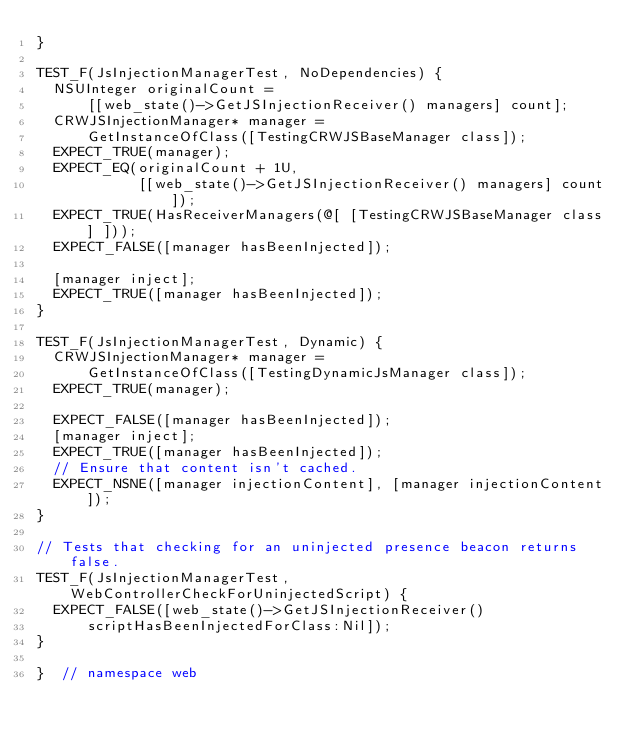<code> <loc_0><loc_0><loc_500><loc_500><_ObjectiveC_>}

TEST_F(JsInjectionManagerTest, NoDependencies) {
  NSUInteger originalCount =
      [[web_state()->GetJSInjectionReceiver() managers] count];
  CRWJSInjectionManager* manager =
      GetInstanceOfClass([TestingCRWJSBaseManager class]);
  EXPECT_TRUE(manager);
  EXPECT_EQ(originalCount + 1U,
            [[web_state()->GetJSInjectionReceiver() managers] count]);
  EXPECT_TRUE(HasReceiverManagers(@[ [TestingCRWJSBaseManager class] ]));
  EXPECT_FALSE([manager hasBeenInjected]);

  [manager inject];
  EXPECT_TRUE([manager hasBeenInjected]);
}

TEST_F(JsInjectionManagerTest, Dynamic) {
  CRWJSInjectionManager* manager =
      GetInstanceOfClass([TestingDynamicJsManager class]);
  EXPECT_TRUE(manager);

  EXPECT_FALSE([manager hasBeenInjected]);
  [manager inject];
  EXPECT_TRUE([manager hasBeenInjected]);
  // Ensure that content isn't cached.
  EXPECT_NSNE([manager injectionContent], [manager injectionContent]);
}

// Tests that checking for an uninjected presence beacon returns false.
TEST_F(JsInjectionManagerTest, WebControllerCheckForUninjectedScript) {
  EXPECT_FALSE([web_state()->GetJSInjectionReceiver()
      scriptHasBeenInjectedForClass:Nil]);
}

}  // namespace web
</code> 